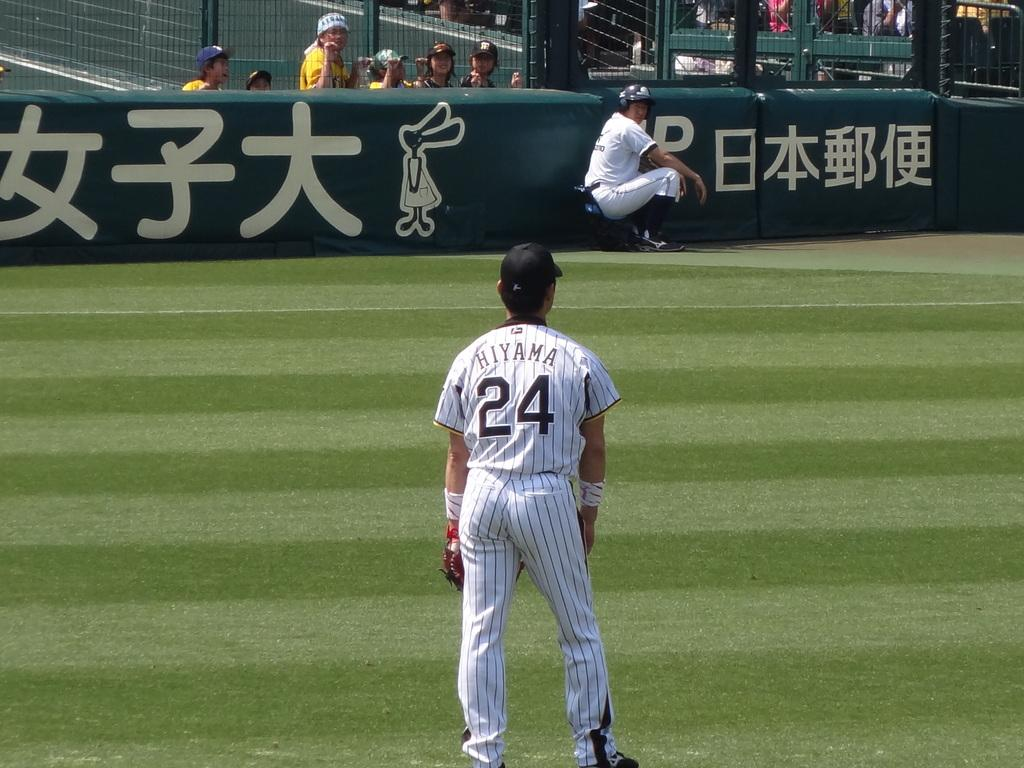<image>
Provide a brief description of the given image. Baseball player wearing number 24 standing on the field. 